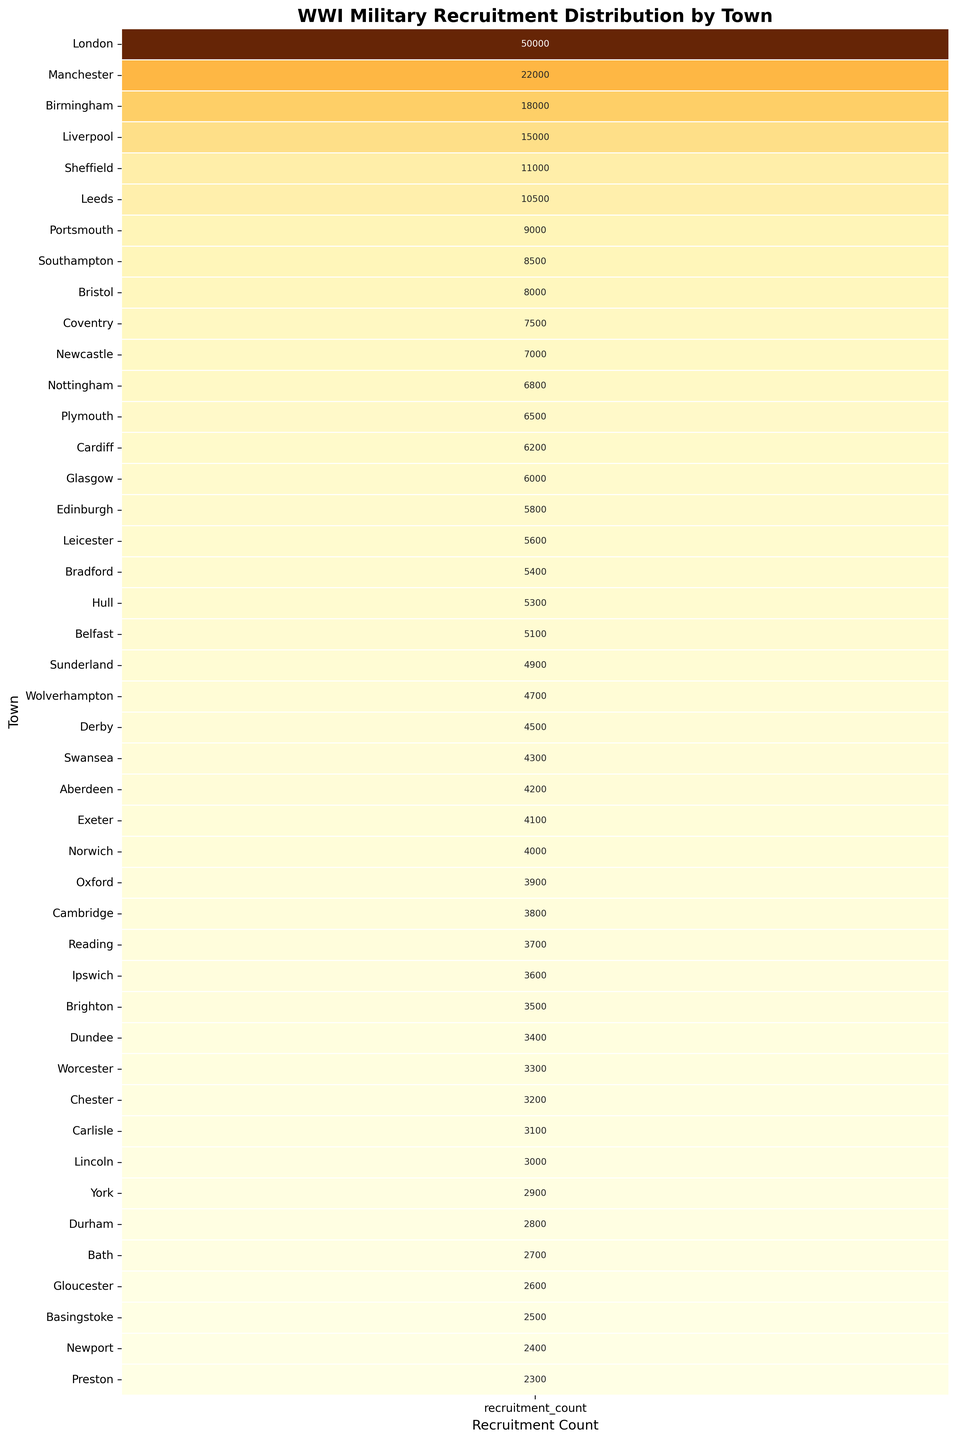Which town has the highest military recruitment count? The heatmap shows recruitment counts for towns with London at the top having the darkest color indicating the highest count.
Answer: London Which town has the lowest military recruitment count? The heatmap shows recruitment counts for towns with Preston at the bottom having the lightest color indicating the lowest count.
Answer: Preston Which town has higher military recruitment count, Manchester or Liverpool? From the heatmap, Manchester has a darker color compared to Liverpool, indicating a higher recruitment count.
Answer: Manchester What is the difference in recruitment counts between Birmingham and Glasgow? The heatmap shows Birmingham with 18,000 and Glasgow with 6,000 recruits. The difference is 18,000 - 6,000 = 12,000.
Answer: 12,000 What is the total recruitment count for the top three towns? From the heatmap, the top three towns are London (50,000), Manchester (22,000), and Birmingham (18,000). Their total is 50,000 + 22,000 + 18,000 = 90,000.
Answer: 90,000 Which town has a recruitment count closest to 10,000? The heatmap shows that Sheffield has the nearest count to 10,000 with a value of 11,000.
Answer: Sheffield What is the median recruitment count of all towns listed? Median is the middle number in a sorted list. The dataset has 45 towns, so the median is the 23rd value when sorted. Sorting the counts, the 23rd town is Norwich with 4,000 recruits.
Answer: 4,000 How does Coventry's recruitment count compare to Southampton's? The heatmap shows Coventry with 7,500 and Southampton with 8,500 recruits. Southampton has a higher count.
Answer: Southampton What is the average recruitment count for the towns shown? Sum all recruitment counts and divide by the number of towns (45). The total sum is 254,700; average is 254,700 / 45 = 5,660.
Answer: 5,660 Which town has a recruitment count exactly half of Birmingham's? Birmingham has a count of 18,000. Half of that is 9,000. The heatmap shows Portsmouth with 9,000 recruits.
Answer: Portsmouth 